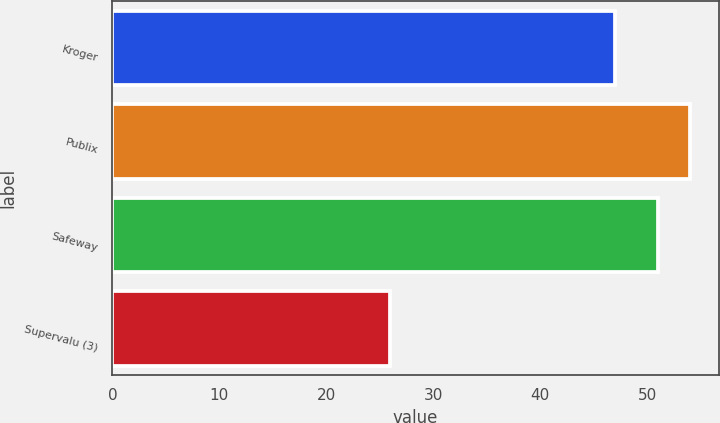Convert chart to OTSL. <chart><loc_0><loc_0><loc_500><loc_500><bar_chart><fcel>Kroger<fcel>Publix<fcel>Safeway<fcel>Supervalu (3)<nl><fcel>47<fcel>54<fcel>51<fcel>26<nl></chart> 